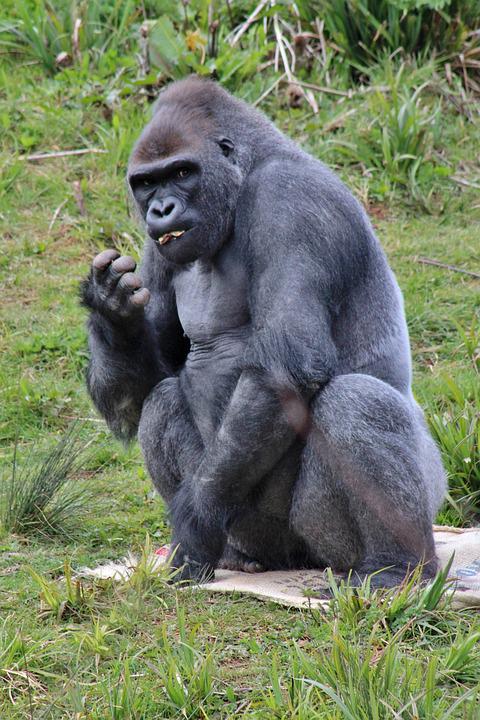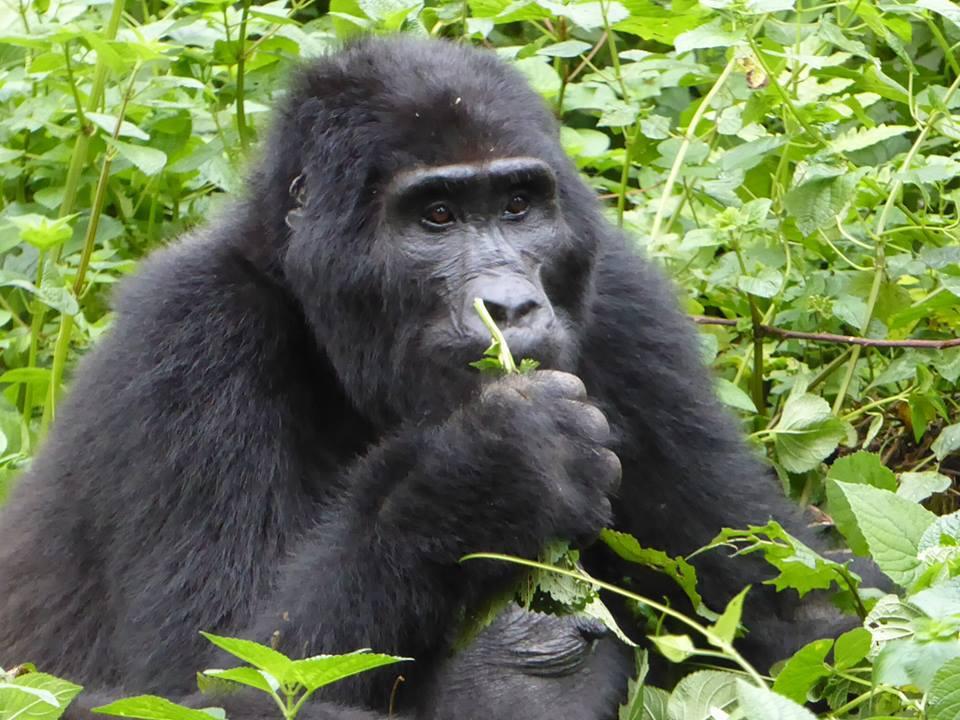The first image is the image on the left, the second image is the image on the right. Given the left and right images, does the statement "In at least one image, a large gorilla has its elbow bent and its hand raised towards its face." hold true? Answer yes or no. Yes. The first image is the image on the left, the second image is the image on the right. Examine the images to the left and right. Is the description "A gorilla is eating a plant in one of the images." accurate? Answer yes or no. Yes. 